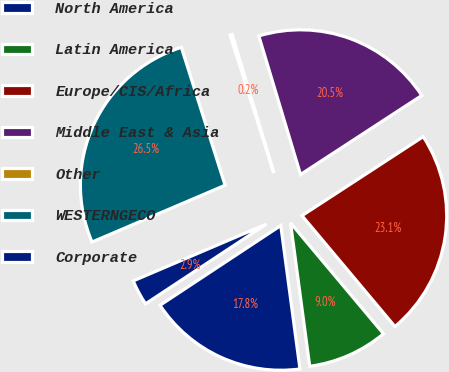<chart> <loc_0><loc_0><loc_500><loc_500><pie_chart><fcel>North America<fcel>Latin America<fcel>Europe/CIS/Africa<fcel>Middle East & Asia<fcel>Other<fcel>WESTERNGECO<fcel>Corporate<nl><fcel>17.83%<fcel>8.99%<fcel>23.09%<fcel>20.46%<fcel>0.24%<fcel>26.53%<fcel>2.87%<nl></chart> 